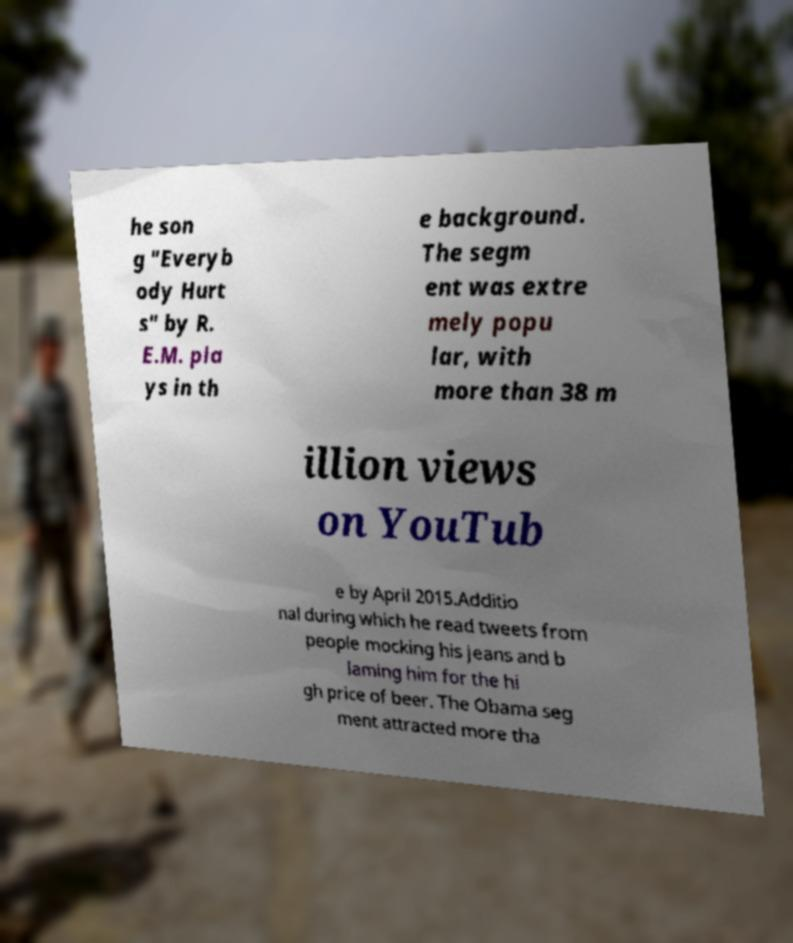Please identify and transcribe the text found in this image. he son g "Everyb ody Hurt s" by R. E.M. pla ys in th e background. The segm ent was extre mely popu lar, with more than 38 m illion views on YouTub e by April 2015.Additio nal during which he read tweets from people mocking his jeans and b laming him for the hi gh price of beer. The Obama seg ment attracted more tha 